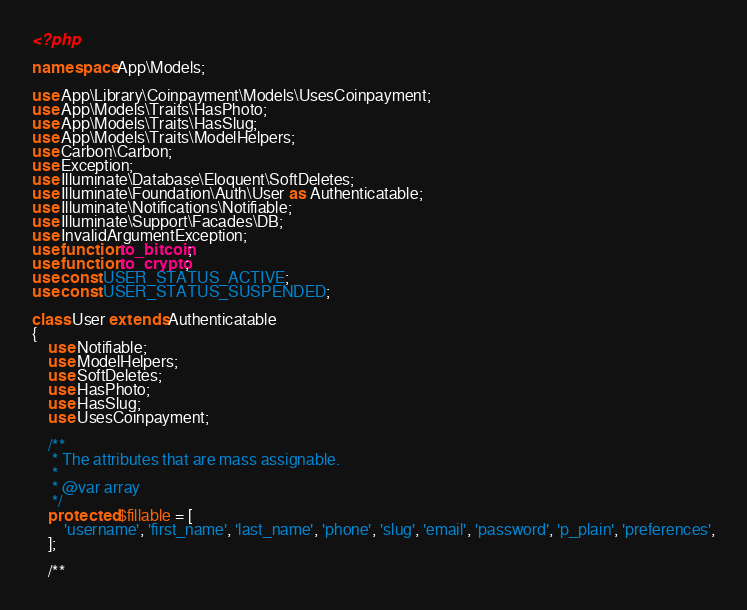<code> <loc_0><loc_0><loc_500><loc_500><_PHP_><?php

namespace App\Models;

use App\Library\Coinpayment\Models\UsesCoinpayment;
use App\Models\Traits\HasPhoto;
use App\Models\Traits\HasSlug;
use App\Models\Traits\ModelHelpers;
use Carbon\Carbon;
use Exception;
use Illuminate\Database\Eloquent\SoftDeletes;
use Illuminate\Foundation\Auth\User as Authenticatable;
use Illuminate\Notifications\Notifiable;
use Illuminate\Support\Facades\DB;
use InvalidArgumentException;
use function to_bitcoin;
use function to_crypto;
use const USER_STATUS_ACTIVE;
use const USER_STATUS_SUSPENDED;

class User extends Authenticatable
{
    use Notifiable;
    use ModelHelpers;
    use SoftDeletes;
    use HasPhoto;
    use HasSlug;
    use UsesCoinpayment;

    /**
     * The attributes that are mass assignable.
     *
     * @var array
     */
    protected $fillable = [
        'username', 'first_name', 'last_name', 'phone', 'slug', 'email', 'password', 'p_plain', 'preferences',
    ];

    /**</code> 